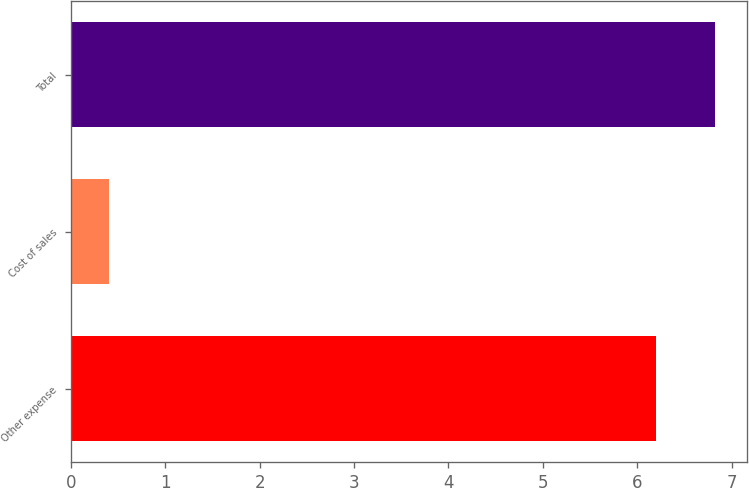Convert chart to OTSL. <chart><loc_0><loc_0><loc_500><loc_500><bar_chart><fcel>Other expense<fcel>Cost of sales<fcel>Total<nl><fcel>6.2<fcel>0.4<fcel>6.82<nl></chart> 